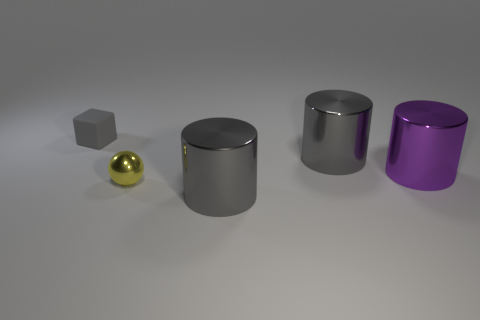Is the color of the large object that is behind the purple thing the same as the matte block?
Your response must be concise. Yes. What is the shape of the large gray thing that is behind the metallic thing that is in front of the tiny yellow thing?
Provide a succinct answer. Cylinder. Are there any other things that have the same color as the small shiny thing?
Give a very brief answer. No. Do the shiny ball and the small cube have the same color?
Your answer should be compact. No. How many brown things are small shiny balls or rubber things?
Provide a short and direct response. 0. Is the number of cylinders in front of the gray rubber object less than the number of red rubber cubes?
Keep it short and to the point. No. There is a tiny object that is right of the matte cube; how many gray rubber things are right of it?
Provide a succinct answer. 0. How many other objects are there of the same size as the yellow object?
Your answer should be very brief. 1. What number of things are either tiny matte objects or yellow spheres in front of the purple cylinder?
Provide a succinct answer. 2. Is the number of cyan matte blocks less than the number of rubber blocks?
Your answer should be very brief. Yes. 